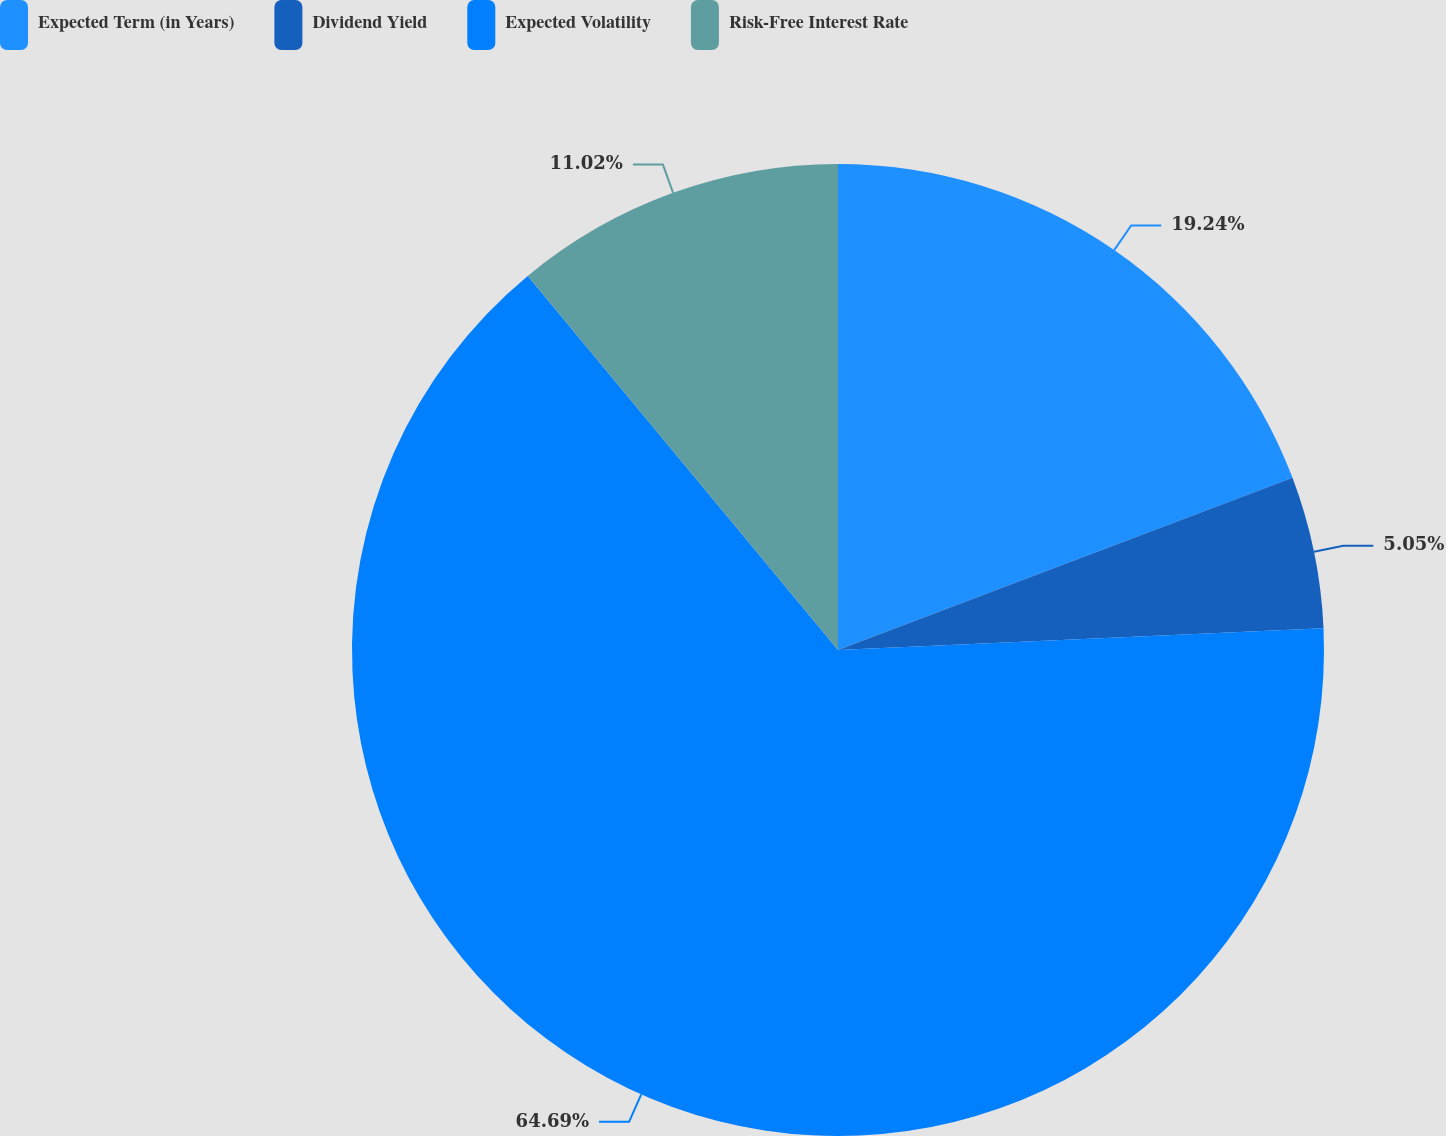Convert chart to OTSL. <chart><loc_0><loc_0><loc_500><loc_500><pie_chart><fcel>Expected Term (in Years)<fcel>Dividend Yield<fcel>Expected Volatility<fcel>Risk-Free Interest Rate<nl><fcel>19.24%<fcel>5.05%<fcel>64.7%<fcel>11.02%<nl></chart> 